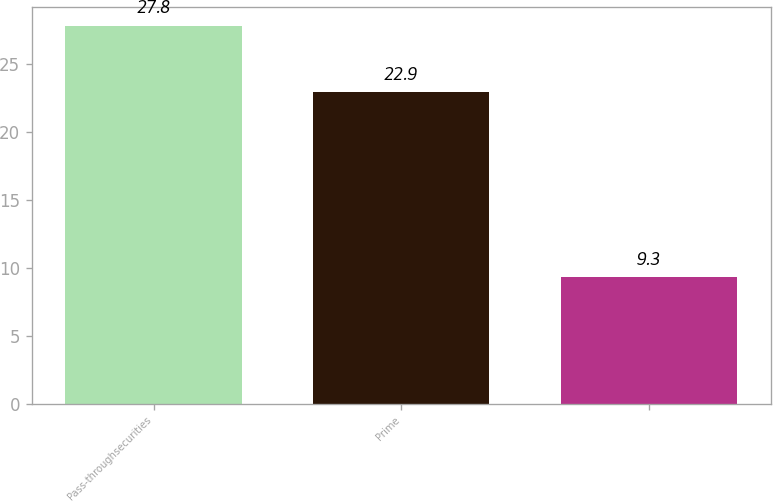<chart> <loc_0><loc_0><loc_500><loc_500><bar_chart><fcel>Pass-throughsecurities<fcel>Prime<fcel>Unnamed: 2<nl><fcel>27.8<fcel>22.9<fcel>9.3<nl></chart> 